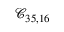Convert formula to latex. <formula><loc_0><loc_0><loc_500><loc_500>\mathcal { C } _ { 3 5 , 1 6 }</formula> 